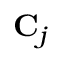Convert formula to latex. <formula><loc_0><loc_0><loc_500><loc_500>C _ { j }</formula> 